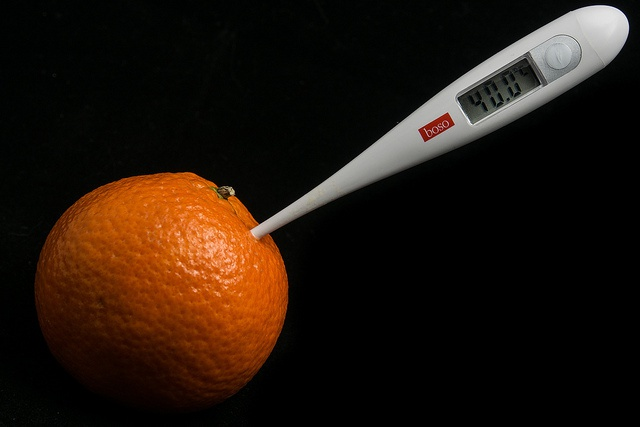Describe the objects in this image and their specific colors. I can see a orange in black, red, maroon, and brown tones in this image. 